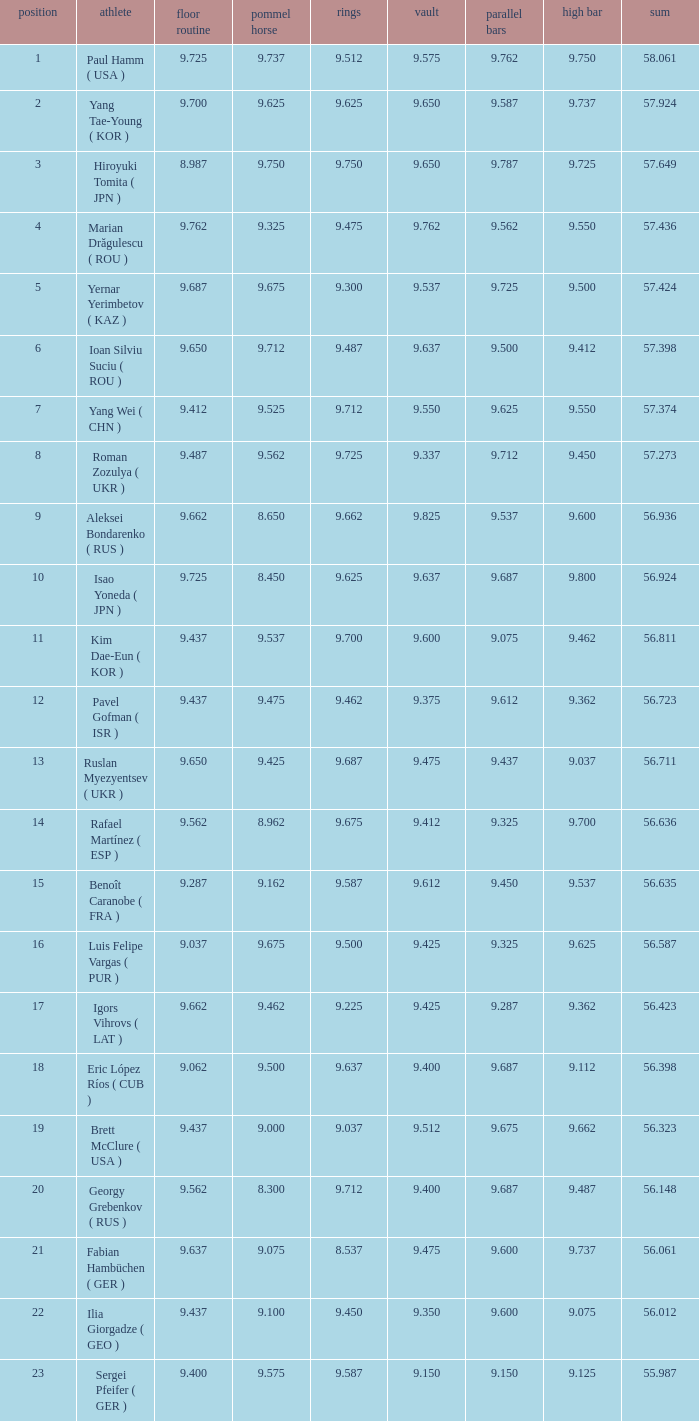What is the vault score for the total of 56.635? 9.612. 